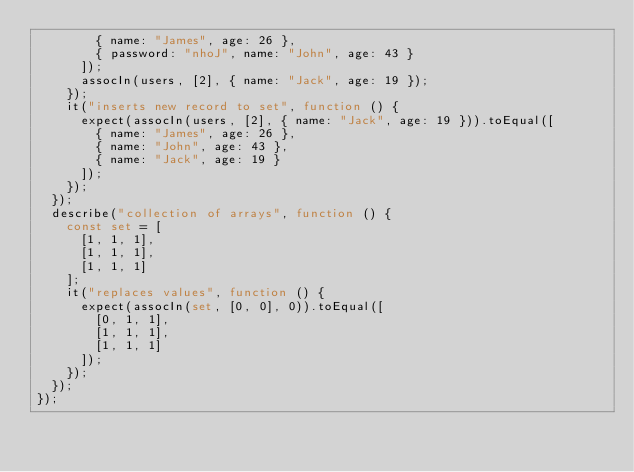<code> <loc_0><loc_0><loc_500><loc_500><_TypeScript_>        { name: "James", age: 26 },
        { password: "nhoJ", name: "John", age: 43 }
      ]);
      assocIn(users, [2], { name: "Jack", age: 19 });
    });
    it("inserts new record to set", function () {
      expect(assocIn(users, [2], { name: "Jack", age: 19 })).toEqual([
        { name: "James", age: 26 },
        { name: "John", age: 43 },
        { name: "Jack", age: 19 }
      ]);
    });
  });
  describe("collection of arrays", function () {
    const set = [
      [1, 1, 1],
      [1, 1, 1],
      [1, 1, 1]
    ];
    it("replaces values", function () {
      expect(assocIn(set, [0, 0], 0)).toEqual([
        [0, 1, 1],
        [1, 1, 1],
        [1, 1, 1]
      ]);
    });
  });
});
</code> 